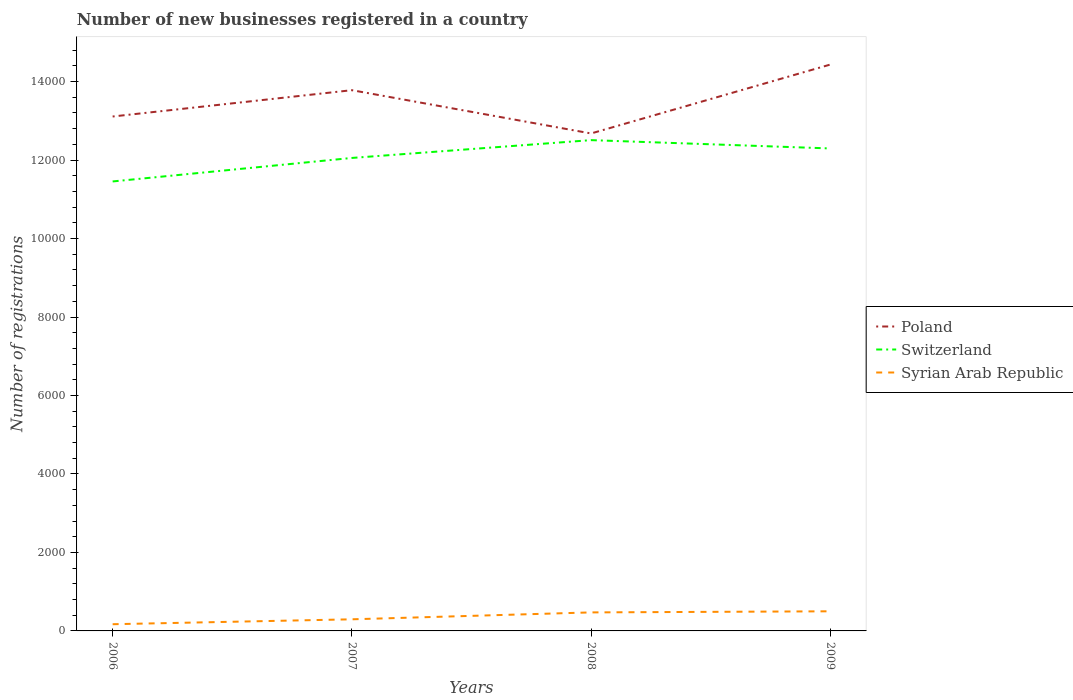Does the line corresponding to Syrian Arab Republic intersect with the line corresponding to Switzerland?
Ensure brevity in your answer.  No. Is the number of lines equal to the number of legend labels?
Offer a very short reply. Yes. Across all years, what is the maximum number of new businesses registered in Syrian Arab Republic?
Provide a succinct answer. 171. In which year was the number of new businesses registered in Syrian Arab Republic maximum?
Provide a short and direct response. 2006. What is the total number of new businesses registered in Syrian Arab Republic in the graph?
Your response must be concise. -329. What is the difference between the highest and the second highest number of new businesses registered in Syrian Arab Republic?
Offer a terse response. 329. What is the difference between the highest and the lowest number of new businesses registered in Switzerland?
Make the answer very short. 2. How many lines are there?
Give a very brief answer. 3. Are the values on the major ticks of Y-axis written in scientific E-notation?
Provide a short and direct response. No. Does the graph contain any zero values?
Provide a short and direct response. No. Does the graph contain grids?
Provide a short and direct response. No. What is the title of the graph?
Offer a terse response. Number of new businesses registered in a country. What is the label or title of the X-axis?
Provide a short and direct response. Years. What is the label or title of the Y-axis?
Ensure brevity in your answer.  Number of registrations. What is the Number of registrations of Poland in 2006?
Provide a succinct answer. 1.31e+04. What is the Number of registrations of Switzerland in 2006?
Provide a short and direct response. 1.15e+04. What is the Number of registrations in Syrian Arab Republic in 2006?
Offer a very short reply. 171. What is the Number of registrations of Poland in 2007?
Ensure brevity in your answer.  1.38e+04. What is the Number of registrations of Switzerland in 2007?
Offer a terse response. 1.21e+04. What is the Number of registrations in Syrian Arab Republic in 2007?
Give a very brief answer. 296. What is the Number of registrations in Poland in 2008?
Give a very brief answer. 1.27e+04. What is the Number of registrations in Switzerland in 2008?
Your answer should be compact. 1.25e+04. What is the Number of registrations in Syrian Arab Republic in 2008?
Provide a short and direct response. 472. What is the Number of registrations in Poland in 2009?
Your response must be concise. 1.44e+04. What is the Number of registrations in Switzerland in 2009?
Provide a short and direct response. 1.23e+04. Across all years, what is the maximum Number of registrations of Poland?
Give a very brief answer. 1.44e+04. Across all years, what is the maximum Number of registrations of Switzerland?
Offer a very short reply. 1.25e+04. Across all years, what is the maximum Number of registrations in Syrian Arab Republic?
Give a very brief answer. 500. Across all years, what is the minimum Number of registrations in Poland?
Give a very brief answer. 1.27e+04. Across all years, what is the minimum Number of registrations in Switzerland?
Your answer should be very brief. 1.15e+04. Across all years, what is the minimum Number of registrations in Syrian Arab Republic?
Your answer should be compact. 171. What is the total Number of registrations of Poland in the graph?
Offer a very short reply. 5.40e+04. What is the total Number of registrations in Switzerland in the graph?
Give a very brief answer. 4.83e+04. What is the total Number of registrations of Syrian Arab Republic in the graph?
Provide a short and direct response. 1439. What is the difference between the Number of registrations of Poland in 2006 and that in 2007?
Provide a short and direct response. -671. What is the difference between the Number of registrations in Switzerland in 2006 and that in 2007?
Give a very brief answer. -599. What is the difference between the Number of registrations in Syrian Arab Republic in 2006 and that in 2007?
Keep it short and to the point. -125. What is the difference between the Number of registrations of Poland in 2006 and that in 2008?
Ensure brevity in your answer.  432. What is the difference between the Number of registrations of Switzerland in 2006 and that in 2008?
Offer a terse response. -1053. What is the difference between the Number of registrations of Syrian Arab Republic in 2006 and that in 2008?
Ensure brevity in your answer.  -301. What is the difference between the Number of registrations of Poland in 2006 and that in 2009?
Provide a short and direct response. -1324. What is the difference between the Number of registrations in Switzerland in 2006 and that in 2009?
Provide a succinct answer. -841. What is the difference between the Number of registrations of Syrian Arab Republic in 2006 and that in 2009?
Provide a succinct answer. -329. What is the difference between the Number of registrations of Poland in 2007 and that in 2008?
Your response must be concise. 1103. What is the difference between the Number of registrations of Switzerland in 2007 and that in 2008?
Your response must be concise. -454. What is the difference between the Number of registrations in Syrian Arab Republic in 2007 and that in 2008?
Your answer should be compact. -176. What is the difference between the Number of registrations of Poland in 2007 and that in 2009?
Give a very brief answer. -653. What is the difference between the Number of registrations of Switzerland in 2007 and that in 2009?
Your answer should be very brief. -242. What is the difference between the Number of registrations in Syrian Arab Republic in 2007 and that in 2009?
Provide a short and direct response. -204. What is the difference between the Number of registrations in Poland in 2008 and that in 2009?
Your response must be concise. -1756. What is the difference between the Number of registrations in Switzerland in 2008 and that in 2009?
Your response must be concise. 212. What is the difference between the Number of registrations of Syrian Arab Republic in 2008 and that in 2009?
Keep it short and to the point. -28. What is the difference between the Number of registrations of Poland in 2006 and the Number of registrations of Switzerland in 2007?
Keep it short and to the point. 1056. What is the difference between the Number of registrations of Poland in 2006 and the Number of registrations of Syrian Arab Republic in 2007?
Provide a succinct answer. 1.28e+04. What is the difference between the Number of registrations in Switzerland in 2006 and the Number of registrations in Syrian Arab Republic in 2007?
Your answer should be very brief. 1.12e+04. What is the difference between the Number of registrations in Poland in 2006 and the Number of registrations in Switzerland in 2008?
Provide a succinct answer. 602. What is the difference between the Number of registrations of Poland in 2006 and the Number of registrations of Syrian Arab Republic in 2008?
Offer a terse response. 1.26e+04. What is the difference between the Number of registrations of Switzerland in 2006 and the Number of registrations of Syrian Arab Republic in 2008?
Keep it short and to the point. 1.10e+04. What is the difference between the Number of registrations of Poland in 2006 and the Number of registrations of Switzerland in 2009?
Offer a very short reply. 814. What is the difference between the Number of registrations in Poland in 2006 and the Number of registrations in Syrian Arab Republic in 2009?
Make the answer very short. 1.26e+04. What is the difference between the Number of registrations of Switzerland in 2006 and the Number of registrations of Syrian Arab Republic in 2009?
Provide a succinct answer. 1.10e+04. What is the difference between the Number of registrations in Poland in 2007 and the Number of registrations in Switzerland in 2008?
Your answer should be compact. 1273. What is the difference between the Number of registrations in Poland in 2007 and the Number of registrations in Syrian Arab Republic in 2008?
Ensure brevity in your answer.  1.33e+04. What is the difference between the Number of registrations of Switzerland in 2007 and the Number of registrations of Syrian Arab Republic in 2008?
Your answer should be very brief. 1.16e+04. What is the difference between the Number of registrations of Poland in 2007 and the Number of registrations of Switzerland in 2009?
Keep it short and to the point. 1485. What is the difference between the Number of registrations in Poland in 2007 and the Number of registrations in Syrian Arab Republic in 2009?
Provide a succinct answer. 1.33e+04. What is the difference between the Number of registrations in Switzerland in 2007 and the Number of registrations in Syrian Arab Republic in 2009?
Keep it short and to the point. 1.16e+04. What is the difference between the Number of registrations of Poland in 2008 and the Number of registrations of Switzerland in 2009?
Your response must be concise. 382. What is the difference between the Number of registrations in Poland in 2008 and the Number of registrations in Syrian Arab Republic in 2009?
Keep it short and to the point. 1.22e+04. What is the difference between the Number of registrations in Switzerland in 2008 and the Number of registrations in Syrian Arab Republic in 2009?
Your response must be concise. 1.20e+04. What is the average Number of registrations in Poland per year?
Provide a succinct answer. 1.35e+04. What is the average Number of registrations in Switzerland per year?
Your answer should be compact. 1.21e+04. What is the average Number of registrations in Syrian Arab Republic per year?
Offer a terse response. 359.75. In the year 2006, what is the difference between the Number of registrations of Poland and Number of registrations of Switzerland?
Offer a very short reply. 1655. In the year 2006, what is the difference between the Number of registrations in Poland and Number of registrations in Syrian Arab Republic?
Make the answer very short. 1.29e+04. In the year 2006, what is the difference between the Number of registrations in Switzerland and Number of registrations in Syrian Arab Republic?
Provide a succinct answer. 1.13e+04. In the year 2007, what is the difference between the Number of registrations in Poland and Number of registrations in Switzerland?
Ensure brevity in your answer.  1727. In the year 2007, what is the difference between the Number of registrations of Poland and Number of registrations of Syrian Arab Republic?
Provide a succinct answer. 1.35e+04. In the year 2007, what is the difference between the Number of registrations of Switzerland and Number of registrations of Syrian Arab Republic?
Provide a short and direct response. 1.18e+04. In the year 2008, what is the difference between the Number of registrations of Poland and Number of registrations of Switzerland?
Give a very brief answer. 170. In the year 2008, what is the difference between the Number of registrations in Poland and Number of registrations in Syrian Arab Republic?
Ensure brevity in your answer.  1.22e+04. In the year 2008, what is the difference between the Number of registrations of Switzerland and Number of registrations of Syrian Arab Republic?
Your answer should be very brief. 1.20e+04. In the year 2009, what is the difference between the Number of registrations of Poland and Number of registrations of Switzerland?
Your answer should be compact. 2138. In the year 2009, what is the difference between the Number of registrations in Poland and Number of registrations in Syrian Arab Republic?
Make the answer very short. 1.39e+04. In the year 2009, what is the difference between the Number of registrations of Switzerland and Number of registrations of Syrian Arab Republic?
Offer a very short reply. 1.18e+04. What is the ratio of the Number of registrations of Poland in 2006 to that in 2007?
Your answer should be compact. 0.95. What is the ratio of the Number of registrations of Switzerland in 2006 to that in 2007?
Provide a succinct answer. 0.95. What is the ratio of the Number of registrations of Syrian Arab Republic in 2006 to that in 2007?
Your response must be concise. 0.58. What is the ratio of the Number of registrations in Poland in 2006 to that in 2008?
Offer a very short reply. 1.03. What is the ratio of the Number of registrations of Switzerland in 2006 to that in 2008?
Your answer should be compact. 0.92. What is the ratio of the Number of registrations of Syrian Arab Republic in 2006 to that in 2008?
Offer a terse response. 0.36. What is the ratio of the Number of registrations in Poland in 2006 to that in 2009?
Keep it short and to the point. 0.91. What is the ratio of the Number of registrations in Switzerland in 2006 to that in 2009?
Keep it short and to the point. 0.93. What is the ratio of the Number of registrations in Syrian Arab Republic in 2006 to that in 2009?
Give a very brief answer. 0.34. What is the ratio of the Number of registrations of Poland in 2007 to that in 2008?
Ensure brevity in your answer.  1.09. What is the ratio of the Number of registrations in Switzerland in 2007 to that in 2008?
Keep it short and to the point. 0.96. What is the ratio of the Number of registrations of Syrian Arab Republic in 2007 to that in 2008?
Your response must be concise. 0.63. What is the ratio of the Number of registrations in Poland in 2007 to that in 2009?
Your response must be concise. 0.95. What is the ratio of the Number of registrations of Switzerland in 2007 to that in 2009?
Give a very brief answer. 0.98. What is the ratio of the Number of registrations in Syrian Arab Republic in 2007 to that in 2009?
Ensure brevity in your answer.  0.59. What is the ratio of the Number of registrations of Poland in 2008 to that in 2009?
Make the answer very short. 0.88. What is the ratio of the Number of registrations of Switzerland in 2008 to that in 2009?
Keep it short and to the point. 1.02. What is the ratio of the Number of registrations of Syrian Arab Republic in 2008 to that in 2009?
Offer a terse response. 0.94. What is the difference between the highest and the second highest Number of registrations in Poland?
Provide a short and direct response. 653. What is the difference between the highest and the second highest Number of registrations of Switzerland?
Keep it short and to the point. 212. What is the difference between the highest and the lowest Number of registrations of Poland?
Your response must be concise. 1756. What is the difference between the highest and the lowest Number of registrations in Switzerland?
Offer a terse response. 1053. What is the difference between the highest and the lowest Number of registrations of Syrian Arab Republic?
Your answer should be compact. 329. 